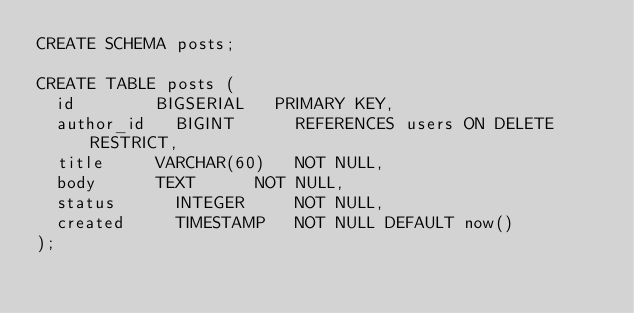Convert code to text. <code><loc_0><loc_0><loc_500><loc_500><_SQL_>CREATE SCHEMA posts;

CREATE TABLE posts (
	id				BIGSERIAL		PRIMARY KEY,
	author_id		BIGINT			REFERENCES users ON DELETE RESTRICT,
	title			VARCHAR(60)		NOT NULL,
	body			TEXT			NOT NULL,
	status			INTEGER			NOT NULL,
	created			TIMESTAMP		NOT NULL DEFAULT now()
);</code> 